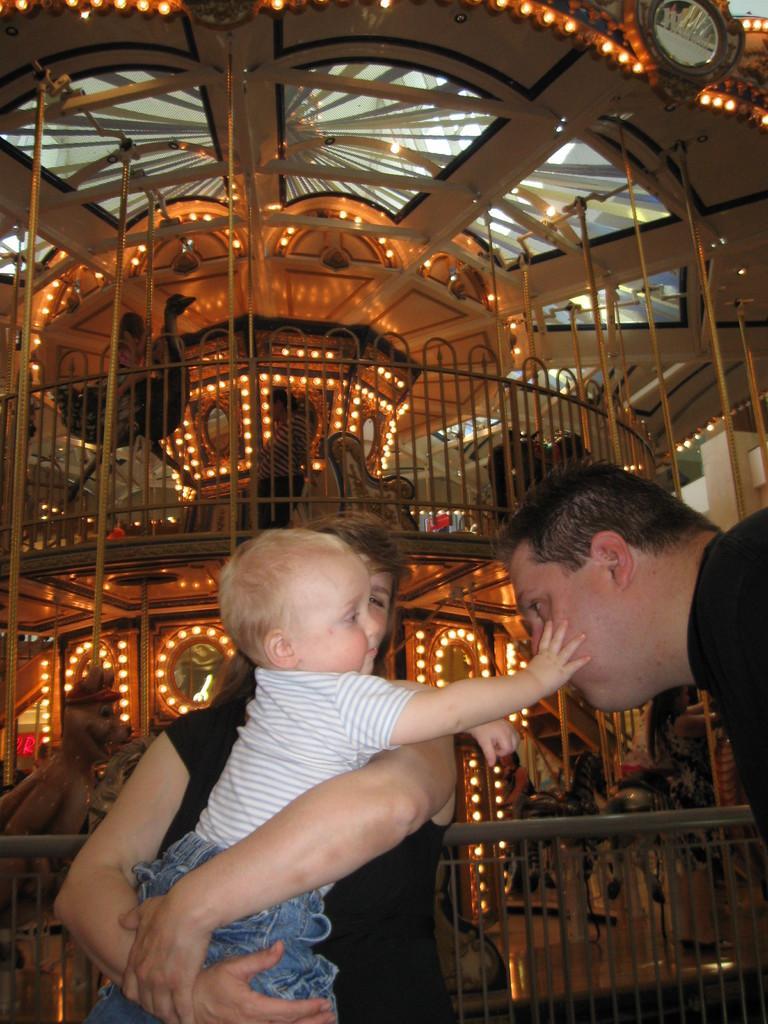Can you describe this image briefly? In this image there is a woman who is holding the kid. The kid is trying to touch the face of a the man who is in front of him. In the background there are lights. It looks like it is a playing ride. 